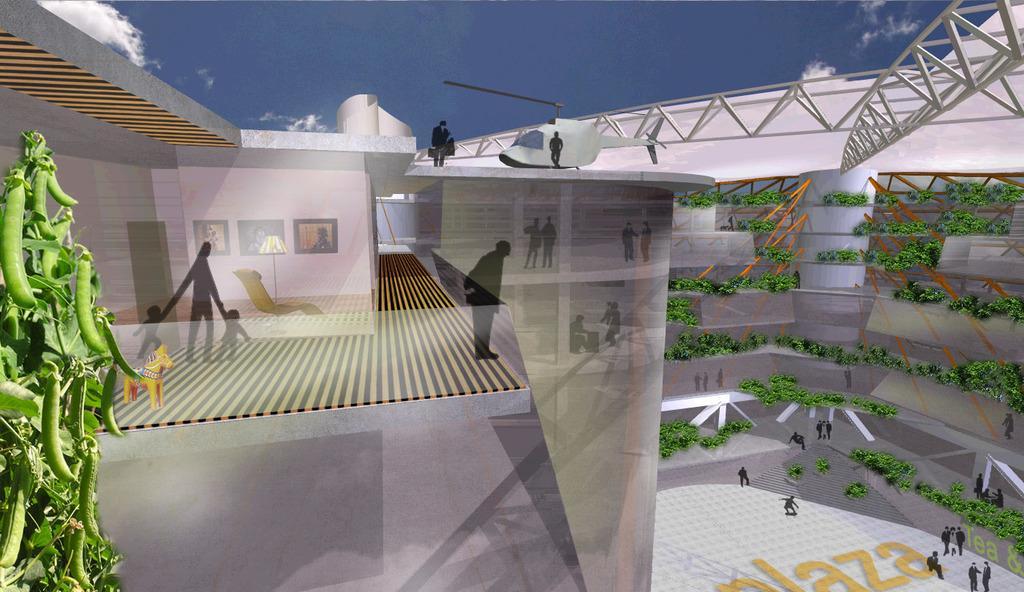Can you describe this image briefly? There is an animated image. On the left side, there is a plant, which is having vegetables. Back to this, there is a building, on which, there is a white color helicopter on the helipad, near other two persons who are standing on the floor. Below this, there are persons on the floor. Below this, there are persons on the ground floor near plants. In the background, there are clouds in the sky. 